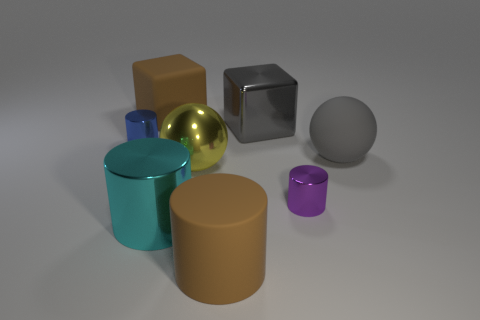Is the number of purple things behind the large brown block greater than the number of balls?
Provide a short and direct response. No. How many things are either big matte things that are in front of the yellow object or cylinders that are in front of the gray ball?
Your answer should be compact. 3. What is the size of the ball that is made of the same material as the brown block?
Offer a terse response. Large. Does the big brown rubber object behind the big rubber sphere have the same shape as the large cyan thing?
Offer a very short reply. No. What is the size of the object that is the same color as the rubber sphere?
Your response must be concise. Large. How many gray objects are large shiny spheres or large rubber objects?
Your answer should be very brief. 1. How many other things are there of the same shape as the blue thing?
Your answer should be very brief. 3. There is a matte thing that is both to the left of the gray rubber ball and in front of the gray metal thing; what is its shape?
Your answer should be compact. Cylinder. Are there any matte objects to the right of the tiny blue shiny cylinder?
Provide a succinct answer. Yes. What size is the brown thing that is the same shape as the large cyan metallic thing?
Provide a succinct answer. Large. 